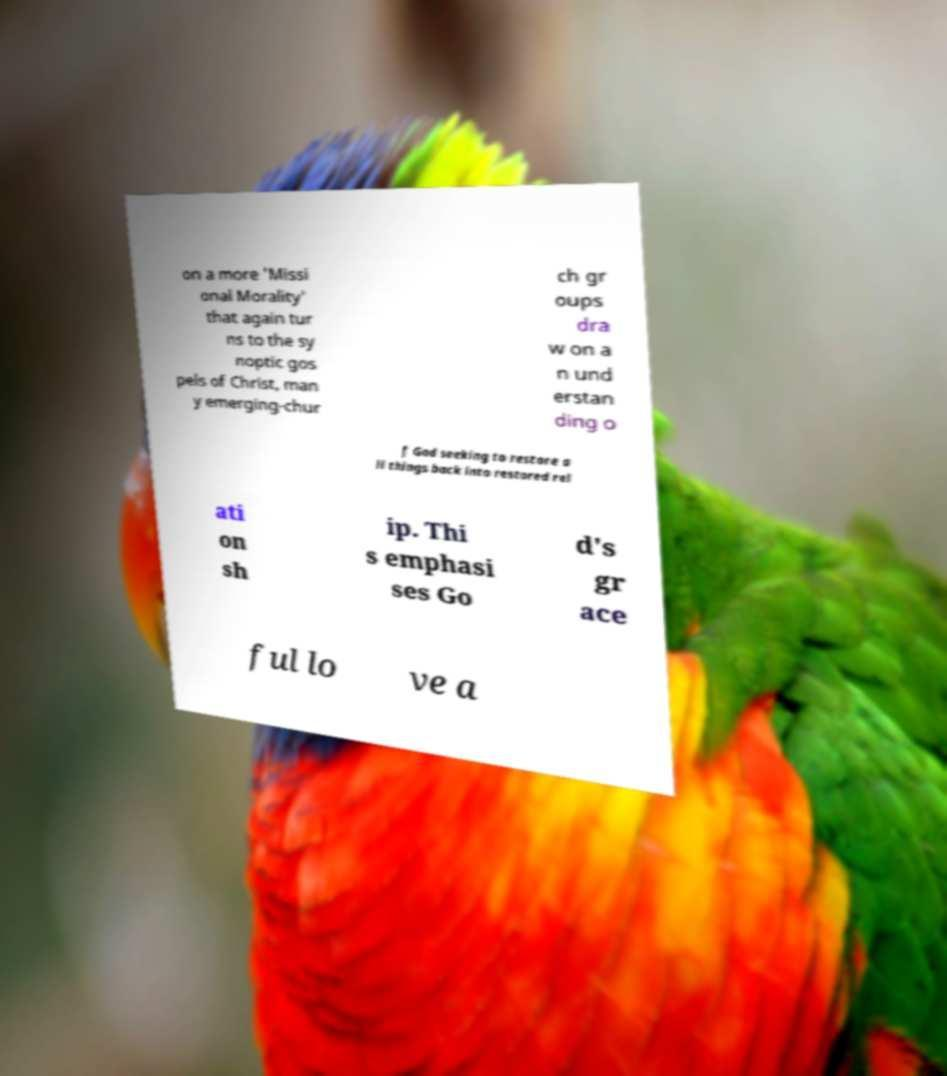Please identify and transcribe the text found in this image. on a more 'Missi onal Morality' that again tur ns to the sy noptic gos pels of Christ, man y emerging-chur ch gr oups dra w on a n und erstan ding o f God seeking to restore a ll things back into restored rel ati on sh ip. Thi s emphasi ses Go d's gr ace ful lo ve a 